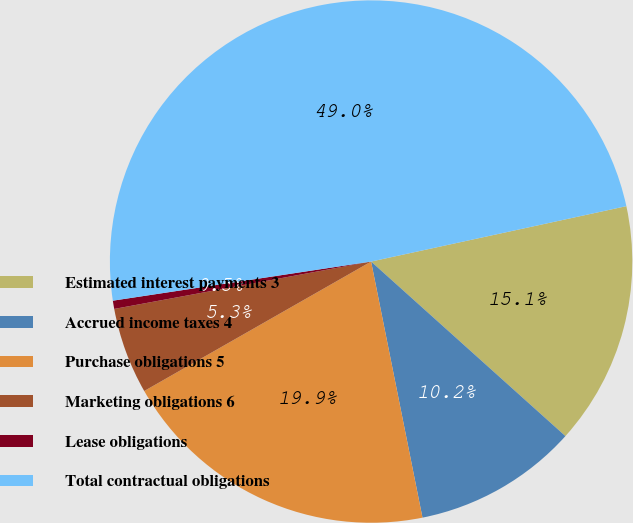Convert chart to OTSL. <chart><loc_0><loc_0><loc_500><loc_500><pie_chart><fcel>Estimated interest payments 3<fcel>Accrued income taxes 4<fcel>Purchase obligations 5<fcel>Marketing obligations 6<fcel>Lease obligations<fcel>Total contractual obligations<nl><fcel>15.05%<fcel>10.2%<fcel>19.9%<fcel>5.35%<fcel>0.51%<fcel>48.99%<nl></chart> 